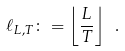Convert formula to latex. <formula><loc_0><loc_0><loc_500><loc_500>\ell _ { L , T } \colon = \left \lfloor \frac { L } { T } \right \rfloor \ .</formula> 